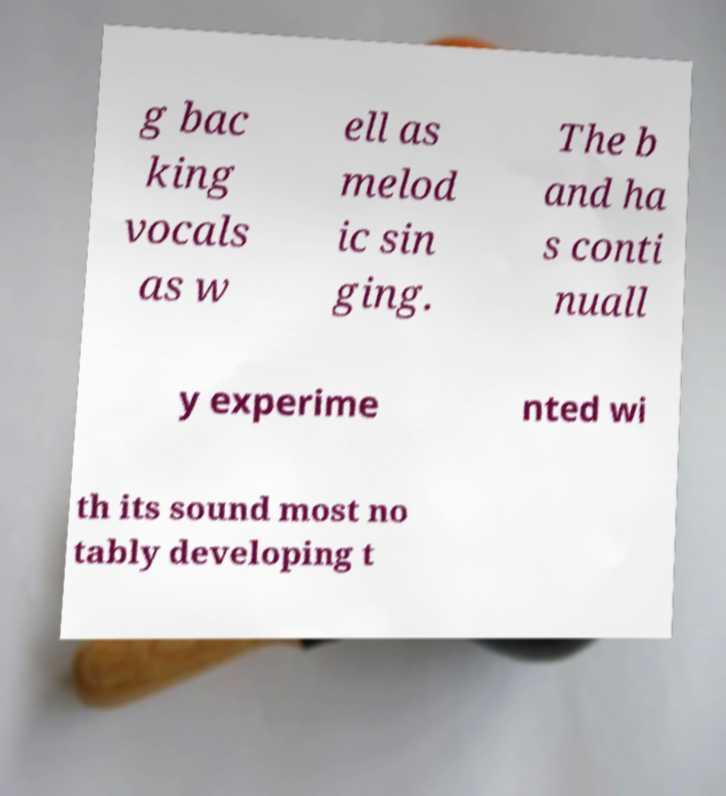Can you read and provide the text displayed in the image?This photo seems to have some interesting text. Can you extract and type it out for me? g bac king vocals as w ell as melod ic sin ging. The b and ha s conti nuall y experime nted wi th its sound most no tably developing t 